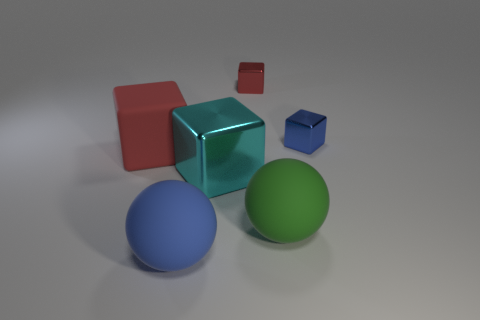What is the material of the other large thing that is the same shape as the red rubber thing?
Make the answer very short. Metal. There is a tiny thing that is left of the small blue object behind the green matte object; are there any metal blocks that are to the right of it?
Offer a very short reply. Yes. There is a large green object; is its shape the same as the rubber thing in front of the green ball?
Give a very brief answer. Yes. Is there anything else that is the same color as the big metallic cube?
Keep it short and to the point. No. Do the big sphere that is to the left of the cyan object and the small metallic block on the right side of the red metallic thing have the same color?
Provide a short and direct response. Yes. Is there a big blue metal object?
Your response must be concise. No. Are there any big blue spheres that have the same material as the big blue thing?
Make the answer very short. No. What color is the large rubber block?
Your answer should be compact. Red. What is the shape of the tiny object that is the same color as the rubber block?
Your answer should be compact. Cube. There is another object that is the same size as the blue metallic thing; what is its color?
Offer a very short reply. Red. 